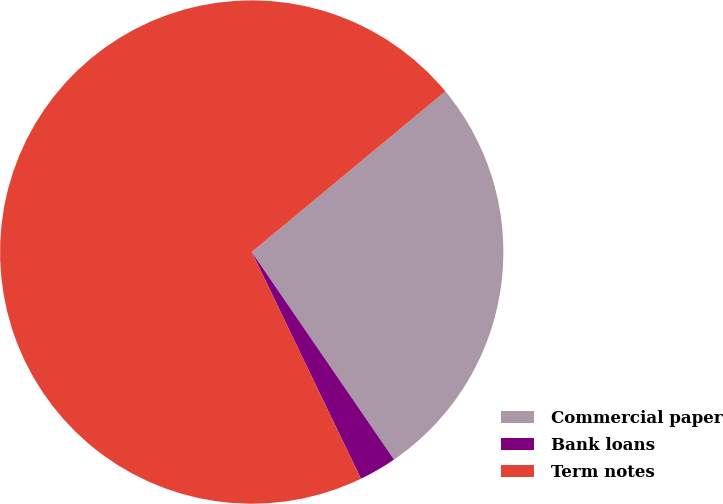Convert chart to OTSL. <chart><loc_0><loc_0><loc_500><loc_500><pie_chart><fcel>Commercial paper<fcel>Bank loans<fcel>Term notes<nl><fcel>26.46%<fcel>2.42%<fcel>71.12%<nl></chart> 